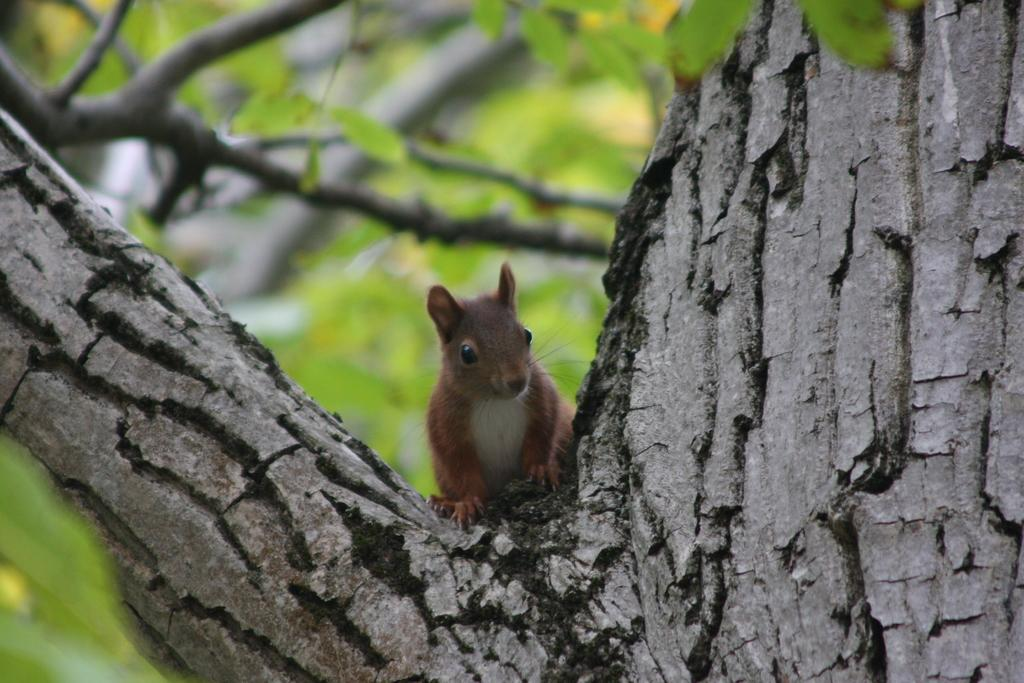What animal can be seen in the image? There is a squirrel in the image. Where is the squirrel located? The squirrel is on a tree. What can be seen in the background of the image? There are trees in the background of the image. How would you describe the background of the image? The background is blurred. Can you see a kite flying near the squirrel in the image? No, there is no kite present in the image. 